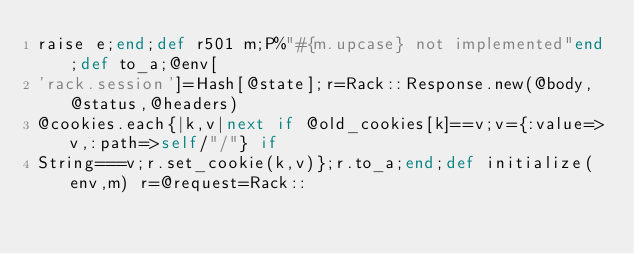Convert code to text. <code><loc_0><loc_0><loc_500><loc_500><_Ruby_>raise e;end;def r501 m;P%"#{m.upcase} not implemented"end;def to_a;@env[
'rack.session']=Hash[@state];r=Rack::Response.new(@body,@status,@headers)
@cookies.each{|k,v|next if @old_cookies[k]==v;v={:value=>v,:path=>self/"/"} if
String===v;r.set_cookie(k,v)};r.to_a;end;def initialize(env,m) r=@request=Rack::</code> 